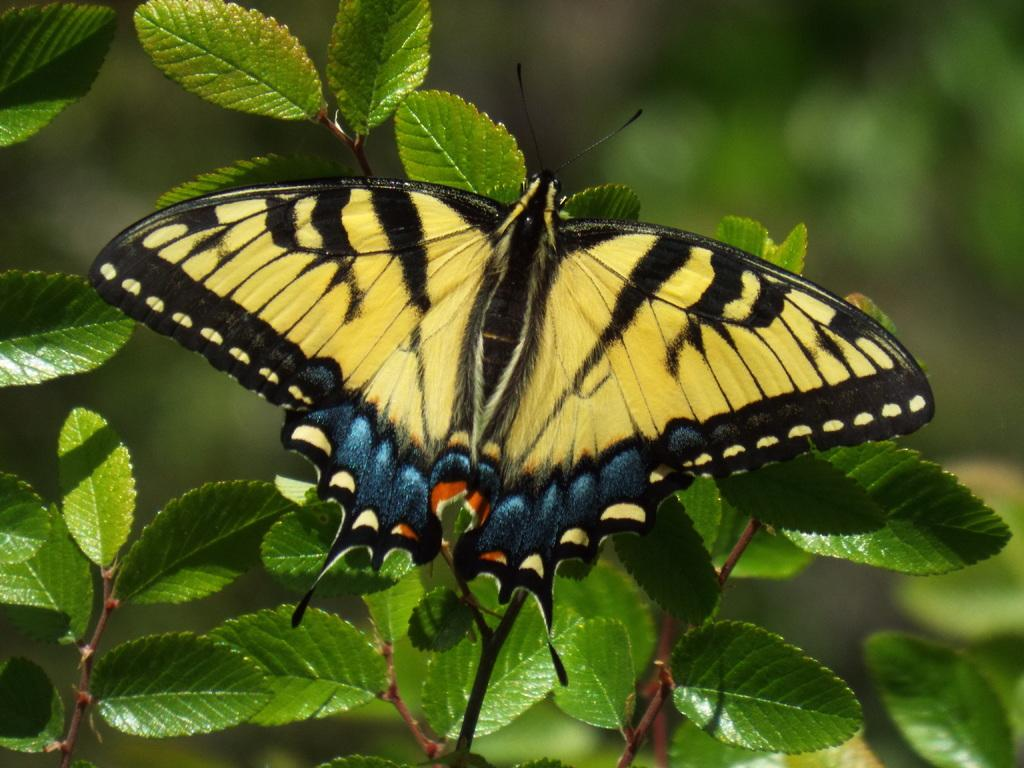What is the main subject of the image? The main subject of the image is a butterfly. What colors can be seen on the butterfly? The butterfly has yellow, blue, and black colors. Where is the butterfly located in the image? The butterfly is on plants. How would you describe the background of the image? The background of the image is blurred. What type of fowl can be seen participating in an activity in the image? There is no fowl or activity present in the image; it features a butterfly on plants with a blurred background. What type of ornament is hanging from the butterfly's wings in the image? There is no ornament present on the butterfly's wings in the image; it has only the colors yellow, blue, and black. 